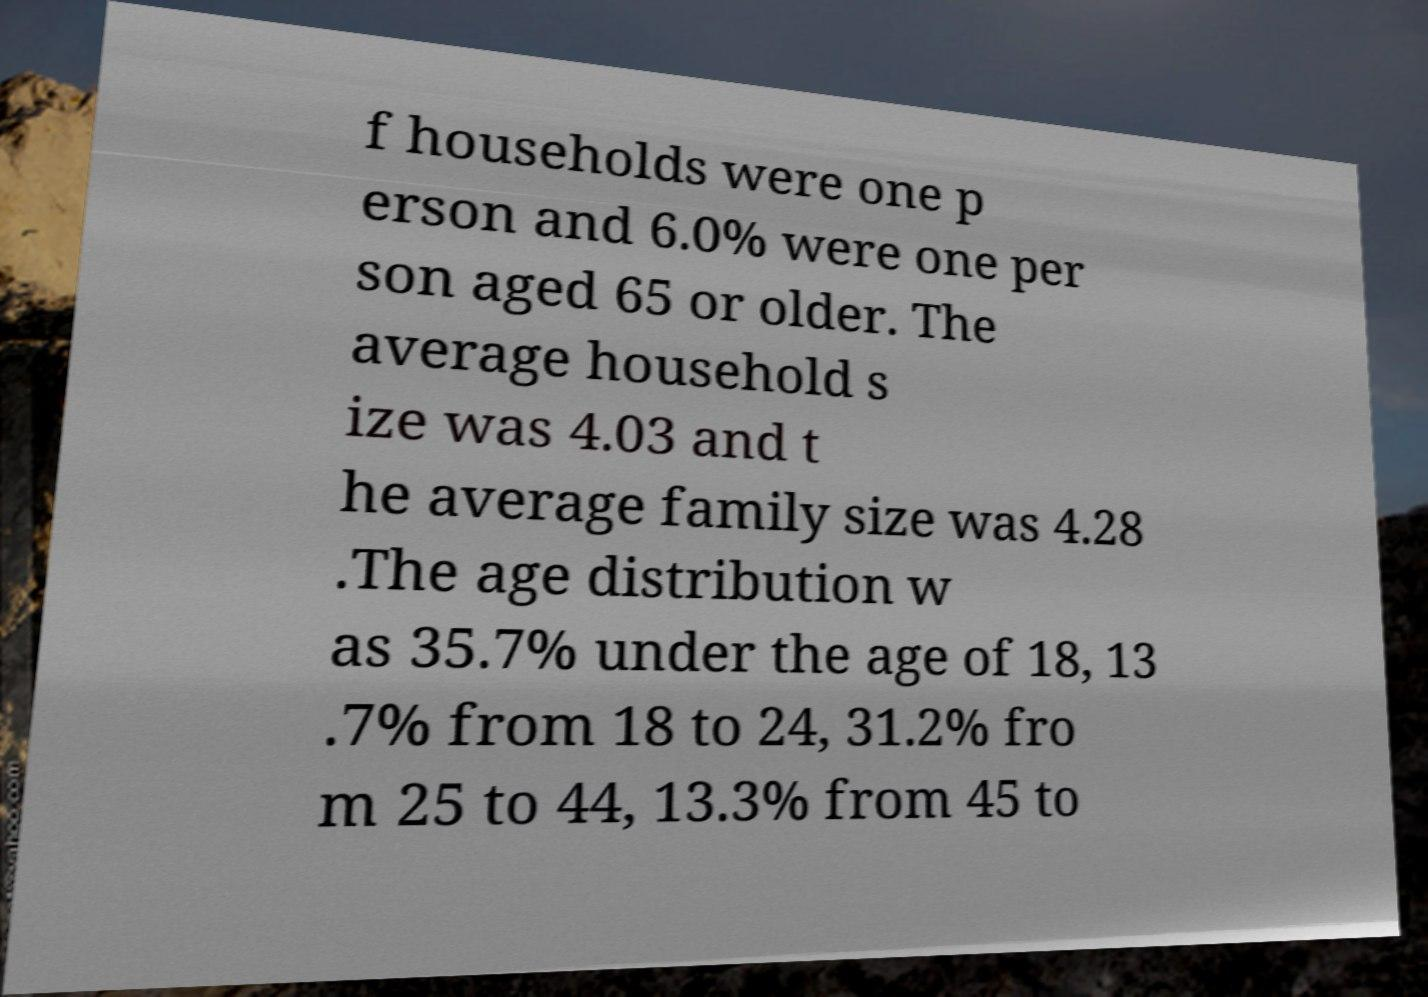Can you accurately transcribe the text from the provided image for me? f households were one p erson and 6.0% were one per son aged 65 or older. The average household s ize was 4.03 and t he average family size was 4.28 .The age distribution w as 35.7% under the age of 18, 13 .7% from 18 to 24, 31.2% fro m 25 to 44, 13.3% from 45 to 